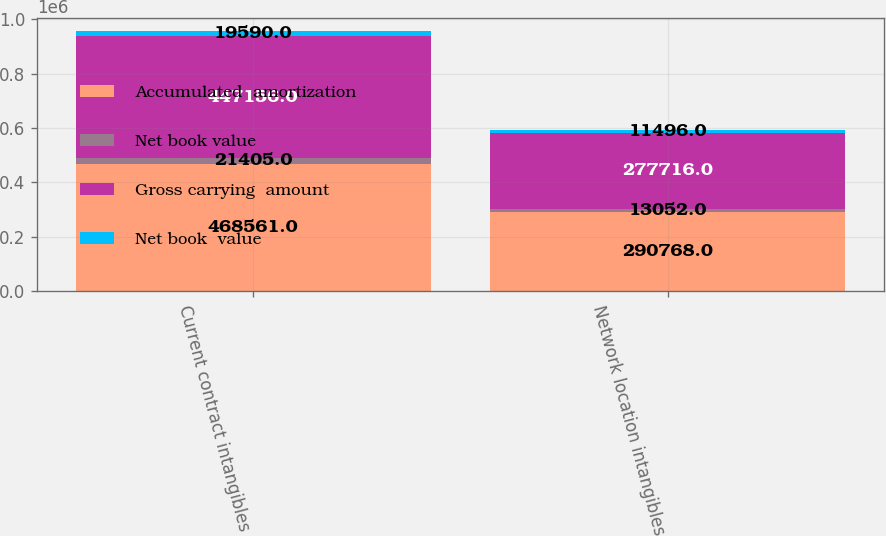<chart> <loc_0><loc_0><loc_500><loc_500><stacked_bar_chart><ecel><fcel>Current contract intangibles<fcel>Network location intangibles<nl><fcel>Accumulated  amortization<fcel>468561<fcel>290768<nl><fcel>Net book value<fcel>21405<fcel>13052<nl><fcel>Gross carrying  amount<fcel>447156<fcel>277716<nl><fcel>Net book  value<fcel>19590<fcel>11496<nl></chart> 